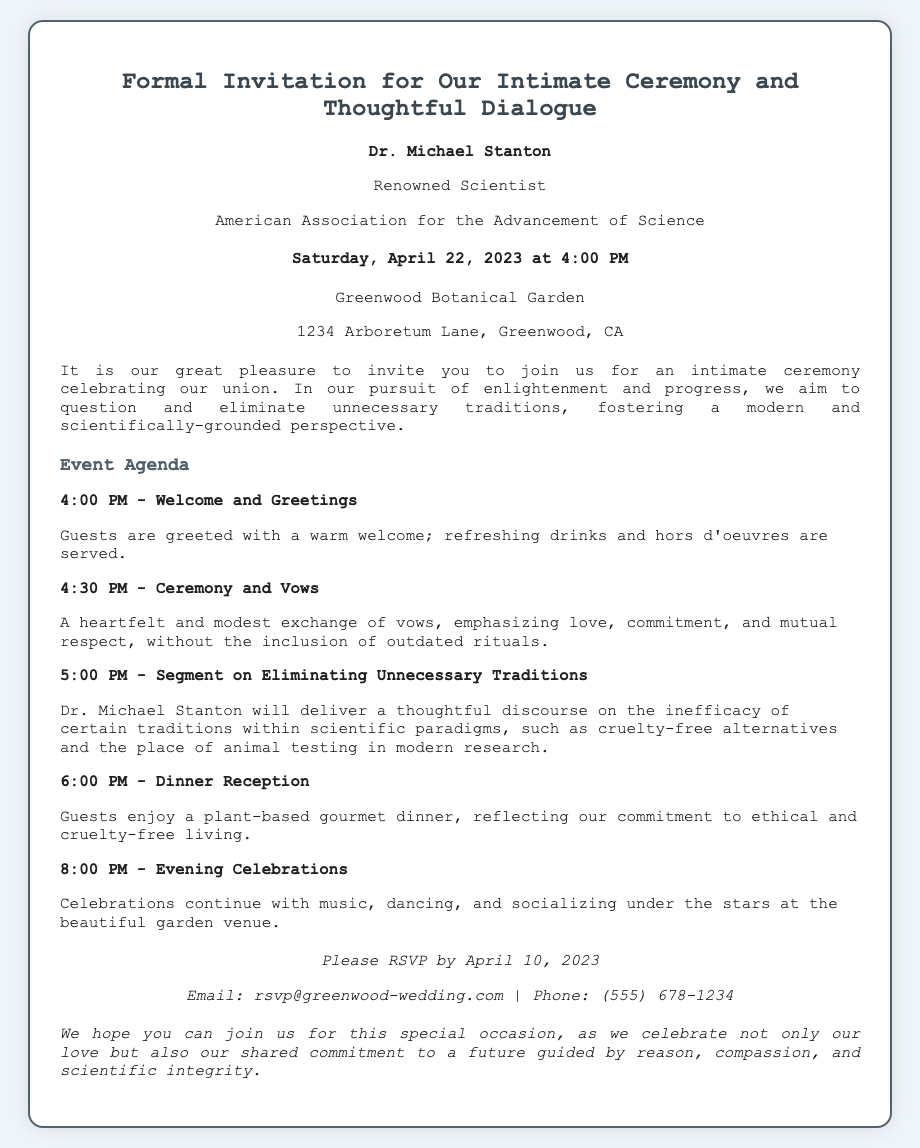What is the name of the host? The host is introduced at the beginning of the invitation as Dr. Michael Stanton.
Answer: Dr. Michael Stanton What is the date of the ceremony? The document specifies that the ceremony will take place on Saturday, April 22, 2023.
Answer: April 22, 2023 Where is the event venue located? The venue address is provided in the invitation as 1234 Arboretum Lane, Greenwood, CA.
Answer: 1234 Arboretum Lane, Greenwood, CA What time does the dinner reception start? The agenda lists that the dinner reception will begin at 6:00 PM.
Answer: 6:00 PM What is the theme of the segment that Dr. Michael Stanton will deliver? The segment focuses on questioning the relevance of certain traditions, particularly in relation to modern scientific practices.
Answer: Eliminating Unnecessary Traditions How many agenda items are there in the event agenda? The agenda contains a total of five items listed for the event.
Answer: Five What type of dinner is being served? The invitation mentions that guests will enjoy a plant-based gourmet dinner.
Answer: Plant-based gourmet dinner What is the RSVP deadline? The invitation specifies that guests should RSVP by April 10, 2023.
Answer: April 10, 2023 What is expected from guests during the evening celebrations? The document states that guests will engage in music, dancing, and socializing.
Answer: Music, dancing, and socializing 